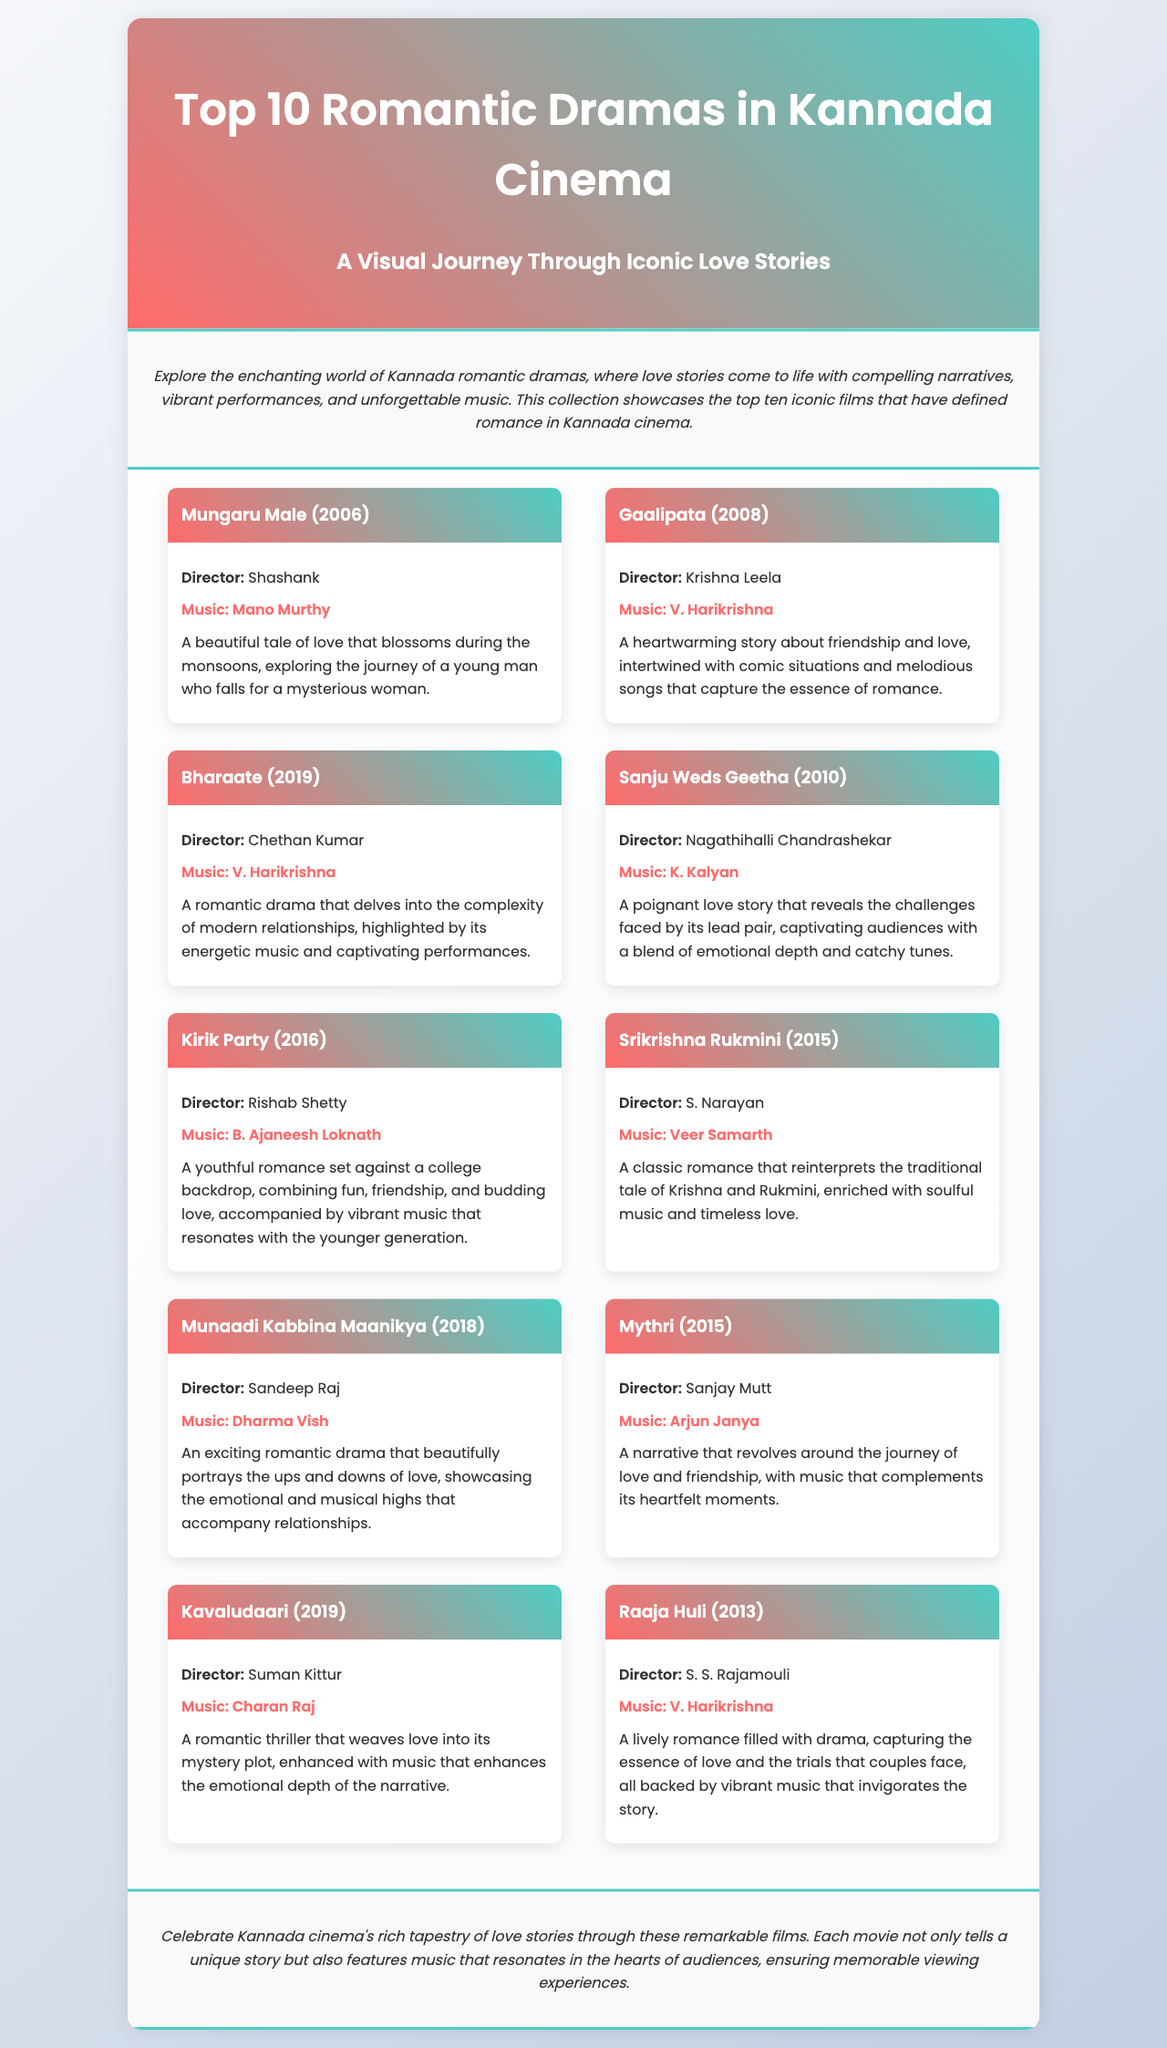What is the title of the brochure? The title of the brochure is prominently displayed at the top of the document.
Answer: Top 10 Romantic Dramas in Kannada Cinema Who directed Mungaru Male? The director's name is listed along with the film title in the document.
Answer: Shashank Which film features music by V. Harikrishna? The document includes the music director's name next to the respective film title, pointing out shared directors.
Answer: Gaalipata, Bharaate, Raaja Huli What year was Kirik Party released? The release year of the film is mentioned alongside the title in the document.
Answer: 2016 What genre do these films represent? The overarching theme is indicated in the introduction and header of the document.
Answer: Romantic dramas Identify a film that has a poignant love story. The description for each film includes terms that highlight the nature of their stories, such as poignant.
Answer: Sanju Weds Geetha What is the main theme of Kavaludaari? The description provides insights about the plot or style of the film, helping to identify its main theme.
Answer: Romantic thriller Which music composer worked on the film Munaadi Kabbina Maanikya? The document specifies the music composers for each film next to their titles.
Answer: Dharma Vish 